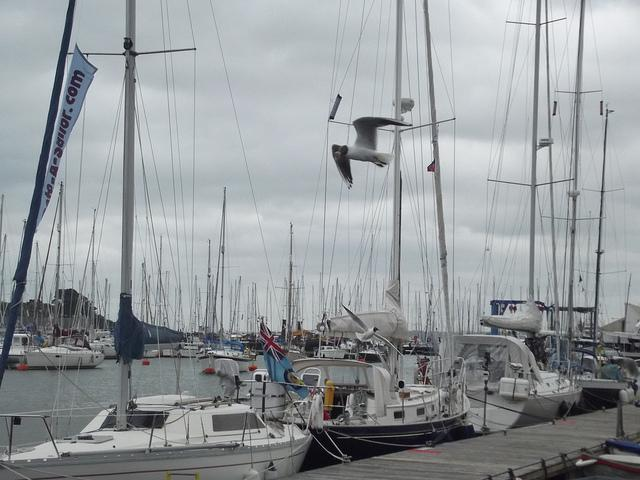What baby name is related to this place? dock 